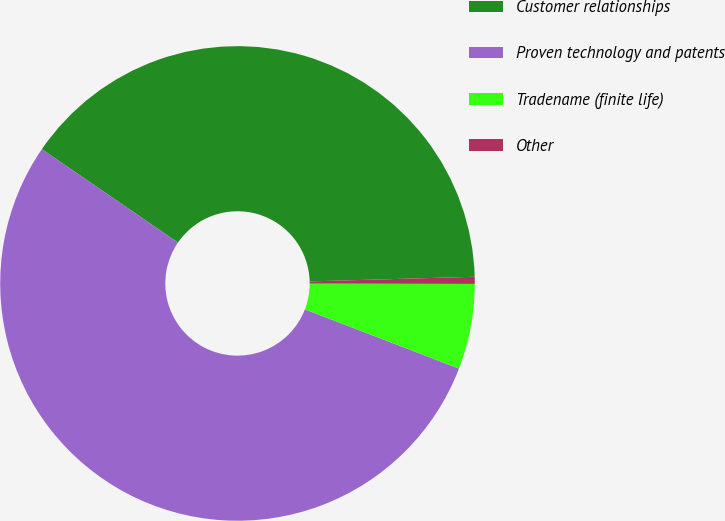Convert chart. <chart><loc_0><loc_0><loc_500><loc_500><pie_chart><fcel>Customer relationships<fcel>Proven technology and patents<fcel>Tradename (finite life)<fcel>Other<nl><fcel>39.98%<fcel>53.73%<fcel>5.81%<fcel>0.48%<nl></chart> 